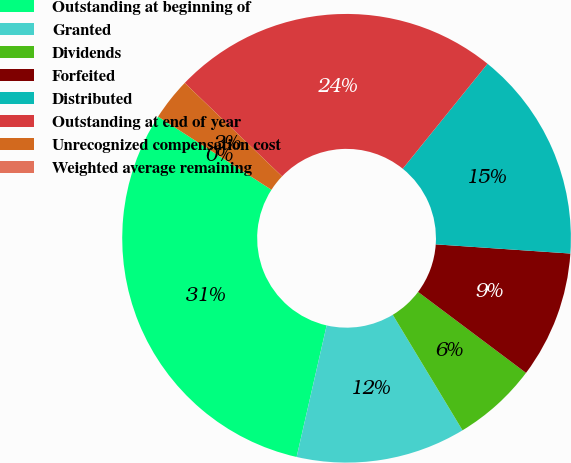Convert chart to OTSL. <chart><loc_0><loc_0><loc_500><loc_500><pie_chart><fcel>Outstanding at beginning of<fcel>Granted<fcel>Dividends<fcel>Forfeited<fcel>Distributed<fcel>Outstanding at end of year<fcel>Unrecognized compensation cost<fcel>Weighted average remaining<nl><fcel>30.55%<fcel>12.22%<fcel>6.11%<fcel>9.16%<fcel>15.27%<fcel>23.64%<fcel>3.05%<fcel>0.0%<nl></chart> 